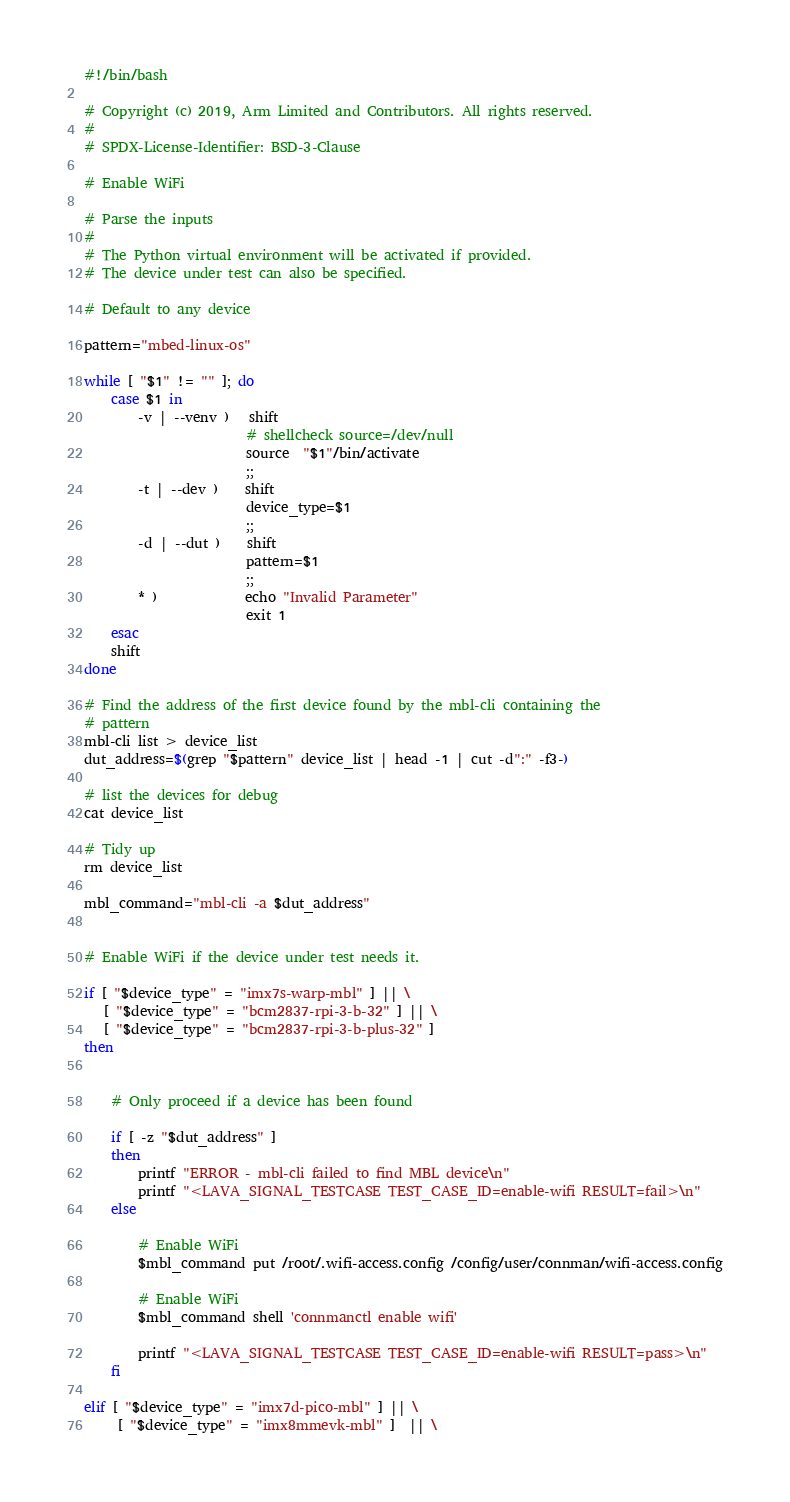<code> <loc_0><loc_0><loc_500><loc_500><_Bash_>#!/bin/bash

# Copyright (c) 2019, Arm Limited and Contributors. All rights reserved.
#
# SPDX-License-Identifier: BSD-3-Clause

# Enable WiFi

# Parse the inputs
#
# The Python virtual environment will be activated if provided.
# The device under test can also be specified.

# Default to any device

pattern="mbed-linux-os"

while [ "$1" != "" ]; do
    case $1 in
        -v | --venv )   shift
                        # shellcheck source=/dev/null
                        source  "$1"/bin/activate
                        ;;
        -t | --dev )    shift
                        device_type=$1
                        ;;
        -d | --dut )    shift
                        pattern=$1
                        ;;
        * )             echo "Invalid Parameter"
                        exit 1
    esac
    shift
done

# Find the address of the first device found by the mbl-cli containing the
# pattern
mbl-cli list > device_list
dut_address=$(grep "$pattern" device_list | head -1 | cut -d":" -f3-)

# list the devices for debug
cat device_list

# Tidy up
rm device_list

mbl_command="mbl-cli -a $dut_address"


# Enable WiFi if the device under test needs it.

if [ "$device_type" = "imx7s-warp-mbl" ] || \
   [ "$device_type" = "bcm2837-rpi-3-b-32" ] || \
   [ "$device_type" = "bcm2837-rpi-3-b-plus-32" ]
then


    # Only proceed if a device has been found

    if [ -z "$dut_address" ]
    then
        printf "ERROR - mbl-cli failed to find MBL device\n"
        printf "<LAVA_SIGNAL_TESTCASE TEST_CASE_ID=enable-wifi RESULT=fail>\n"
    else

        # Enable WiFi
        $mbl_command put /root/.wifi-access.config /config/user/connman/wifi-access.config

        # Enable WiFi
        $mbl_command shell 'connmanctl enable wifi'

        printf "<LAVA_SIGNAL_TESTCASE TEST_CASE_ID=enable-wifi RESULT=pass>\n"
    fi

elif [ "$device_type" = "imx7d-pico-mbl" ] || \
     [ "$device_type" = "imx8mmevk-mbl" ]  || \</code> 